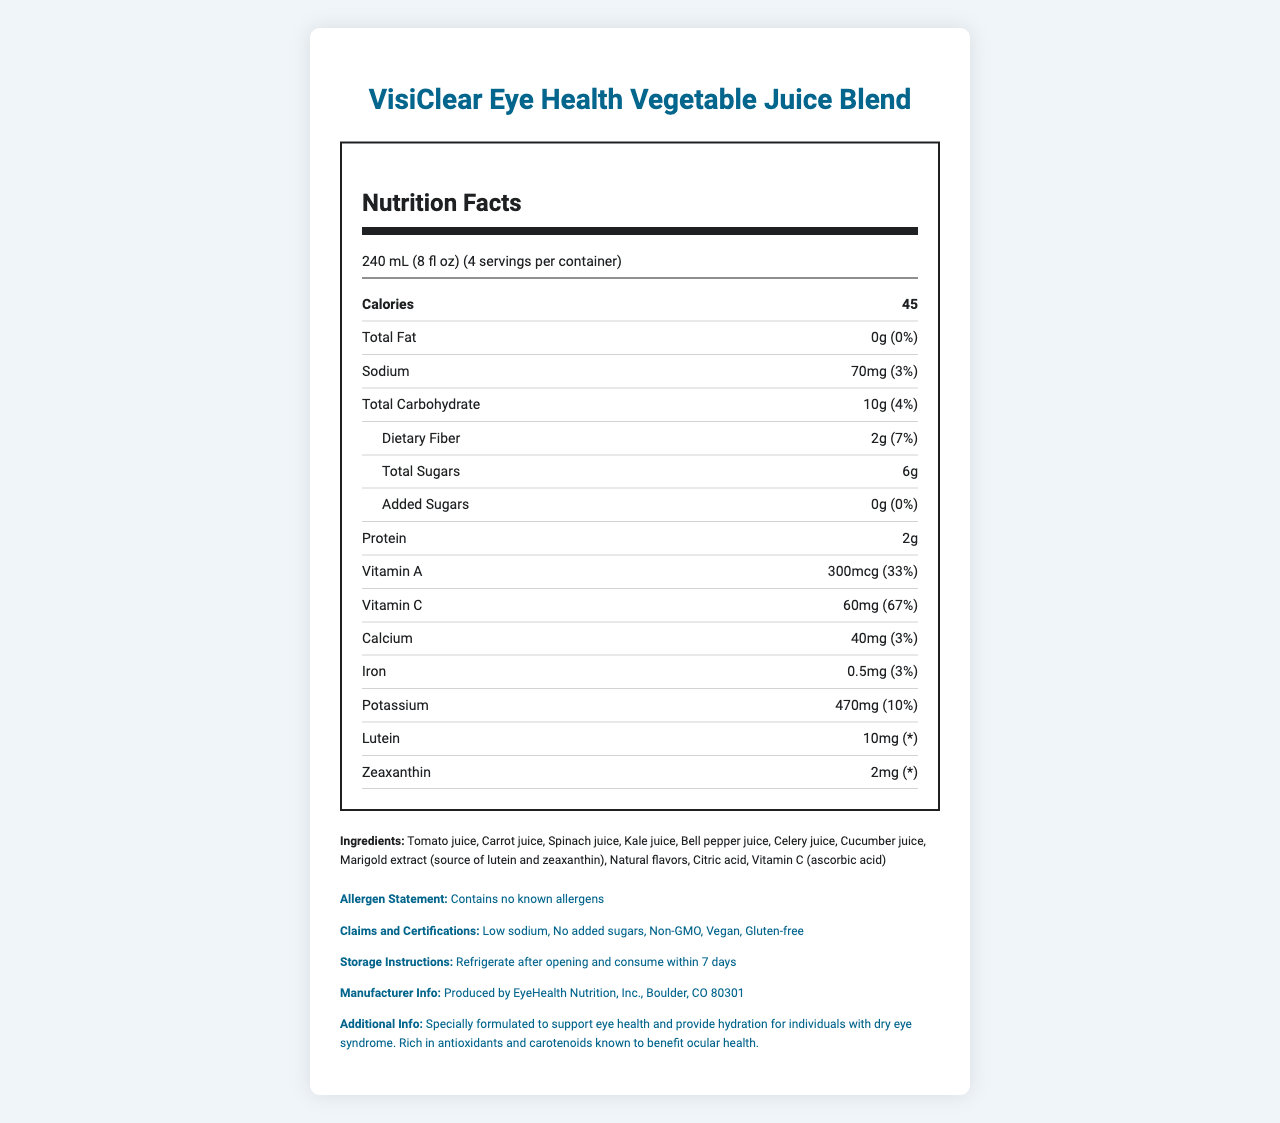what is the serving size of the VisiClear Eye Health Vegetable Juice Blend? The serving size is clearly mentioned in the document under the Nutrition Facts section.
Answer: 240 mL (8 fl oz) how many calories are in one serving? The document states that each serving contains 45 calories in the Nutrition Facts section.
Answer: 45 what is the total fat content per serving? The document lists 0g of total fat per serving in the Nutrition Facts section.
Answer: 0g how much Vitamin C is in each serving and what percentage of the daily value does it provide? According to the document, each serving contains 60mg of Vitamin C, which is 67% of the daily value.
Answer: 60mg, 67% what are the main ingredients in the VisiClear Eye Health Vegetable Juice Blend? The main ingredients are listed in the Ingredients section of the document.
Answer: Tomato juice, Carrot juice, Spinach juice, Kale juice, Bell pepper juice, Celery juice, Cucumber juice, Marigold extract (source of lutein and zeaxanthin), Natural flavors, Citric acid, Vitamin C (ascorbic acid) how much sodium is in a serving, and what percentage of the daily value does it represent? The Nutrition Facts section indicates that each serving contains 70mg of sodium, which is 3% of the daily value.
Answer: 70mg, 3% how many grams of dietary fiber are present per serving? The amount of dietary fiber per serving is stated to be 2g in the Nutrition Facts section.
Answer: 2g what claims and certifications does this product have? These claims and certifications are listed in the Claims and Certifications section of the document.
Answer: Low sodium, No added sugars, Non-GMO, Vegan, Gluten-free how many servings are there in one container? The number of servings per container is clearly mentioned in the document.
Answer: 4 does this product contain any allergens? The allergen statement in the document mentions that the product contains no known allergens.
Answer: no how much protein is in one serving? A. 0g B. 2g C. 5g D. 10g According to the document, one serving contains 2g of protein.
Answer: B which vitamin provides the highest percentage of the daily value per serving? A. Vitamin A B. Vitamin C C. Calcium D. Iron The document indicates that Vitamin C provides 67% of the daily value, which is higher than the other options listed.
Answer: B is this product suitable for vegans? The document lists "Vegan" under Claims and Certifications, indicating suitability for vegans.
Answer: yes describe the main idea of the VisiClear Eye Health Vegetable Juice Blend document. This document offers information on serving size, nutritional contents, ingredients, allergen statements, and claims, emphasizing the benefits of the product for eye health and suitability for people with dry eyes.
Answer: The VisiClear Eye Health Vegetable Juice Blend is designed to support eye health and provide hydration for individuals with dry eye syndrome. It contains a blend of vegetable juices and is fortified with lutein and zeaxanthin, vitamins A and C, dietary fiber, and other nutrients. It is low in sodium, has no added sugars, and is suitable for a vegan, gluten-free, and non-GMO diet. The document provides detailed nutritional information, ingredients, and storage instructions. how does the amount of potassium compare to other minerals listed per serving? The document shows that potassium has 470mg per serving, which is higher than calcium, iron, and sodium listed.
Answer: highest what is the source of lutein and zeaxanthin in the product? The Ingredients section indicates that Marigold extract is the source of lutein and zeaxanthin.
Answer: Marigold extract why is it important to refrigerate the product after opening? The Storage Instructions mention refrigerating after opening to ensure the product stays fresh and is consumed within 7 days.
Answer: to maintain freshness and prevent spoilage can the exact formulation and production process of the juice be determined from the document? The document provides nutritional information, ingredients, and general product claims but does not detail the formulation or production process.
Answer: cannot be determined 